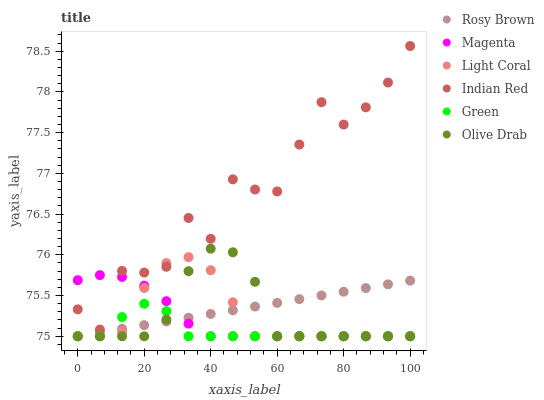Does Green have the minimum area under the curve?
Answer yes or no. Yes. Does Indian Red have the maximum area under the curve?
Answer yes or no. Yes. Does Light Coral have the minimum area under the curve?
Answer yes or no. No. Does Light Coral have the maximum area under the curve?
Answer yes or no. No. Is Rosy Brown the smoothest?
Answer yes or no. Yes. Is Indian Red the roughest?
Answer yes or no. Yes. Is Light Coral the smoothest?
Answer yes or no. No. Is Light Coral the roughest?
Answer yes or no. No. Does Rosy Brown have the lowest value?
Answer yes or no. Yes. Does Indian Red have the lowest value?
Answer yes or no. No. Does Indian Red have the highest value?
Answer yes or no. Yes. Does Light Coral have the highest value?
Answer yes or no. No. Is Rosy Brown less than Indian Red?
Answer yes or no. Yes. Is Indian Red greater than Green?
Answer yes or no. Yes. Does Rosy Brown intersect Green?
Answer yes or no. Yes. Is Rosy Brown less than Green?
Answer yes or no. No. Is Rosy Brown greater than Green?
Answer yes or no. No. Does Rosy Brown intersect Indian Red?
Answer yes or no. No. 